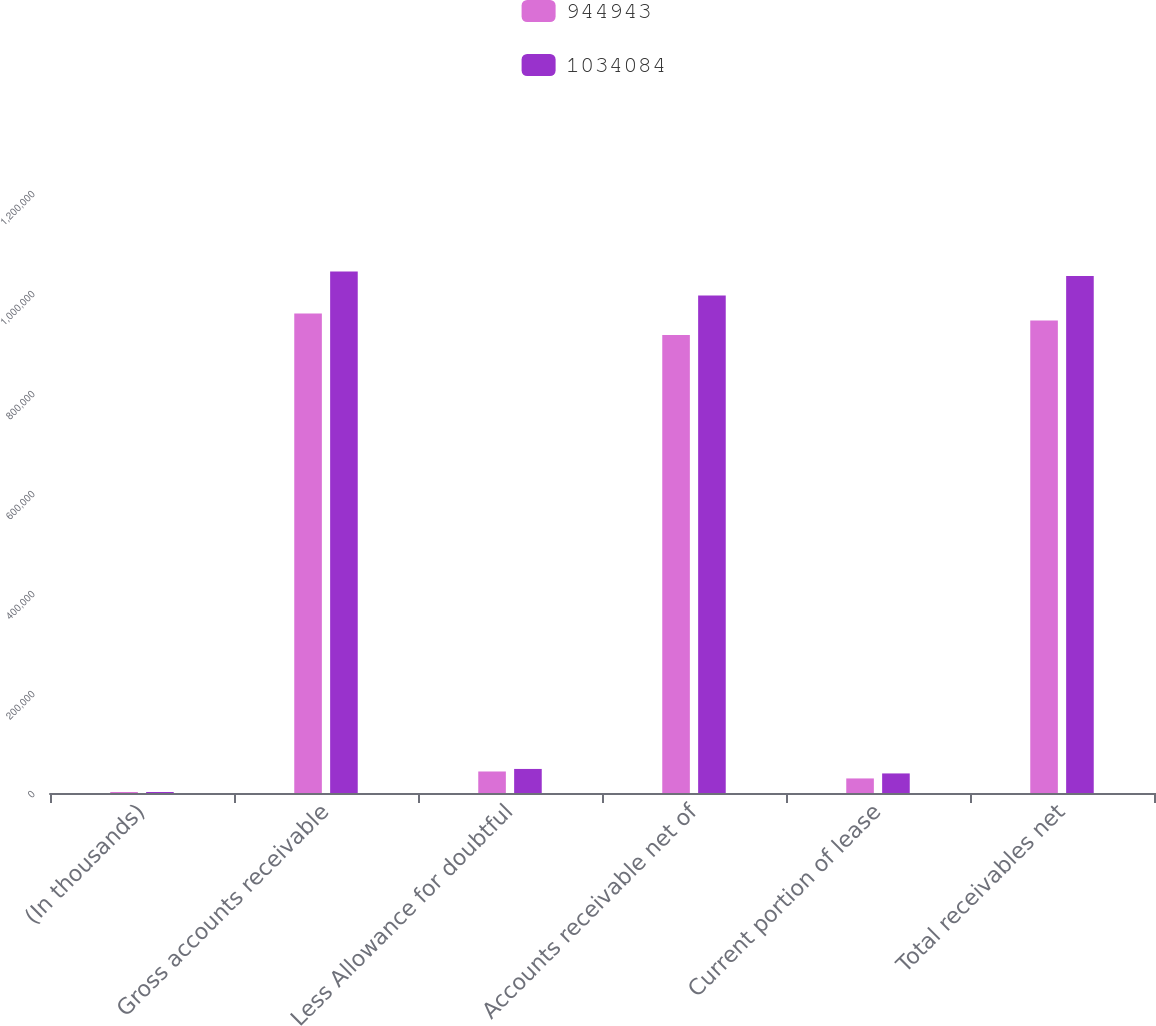Convert chart. <chart><loc_0><loc_0><loc_500><loc_500><stacked_bar_chart><ecel><fcel>(In thousands)<fcel>Gross accounts receivable<fcel>Less Allowance for doubtful<fcel>Accounts receivable net of<fcel>Current portion of lease<fcel>Total receivables net<nl><fcel>944943<fcel>2016<fcel>958843<fcel>43028<fcel>915815<fcel>29128<fcel>944943<nl><fcel>1.03408e+06<fcel>2015<fcel>1.04307e+06<fcel>48119<fcel>994950<fcel>39134<fcel>1.03408e+06<nl></chart> 